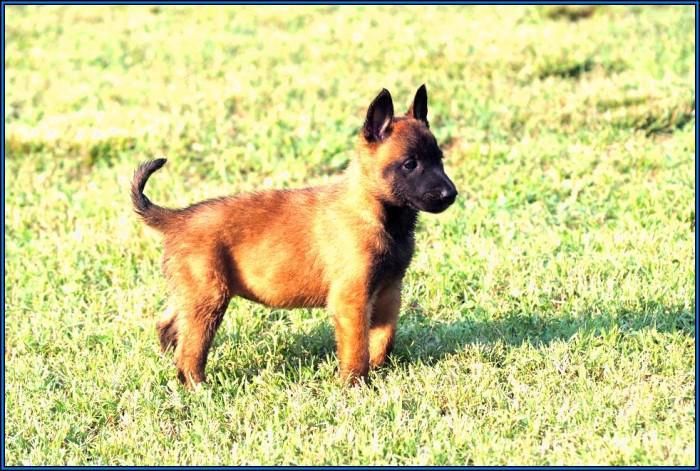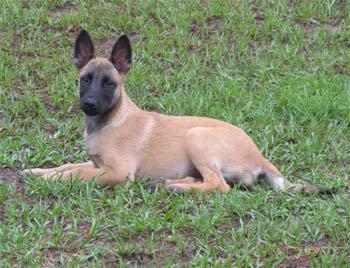The first image is the image on the left, the second image is the image on the right. Examine the images to the left and right. Is the description "the right image has a dog standing on all 4's with a taught leash" accurate? Answer yes or no. No. The first image is the image on the left, the second image is the image on the right. Analyze the images presented: Is the assertion "There is a total of 1 dog facing right is a grassy area." valid? Answer yes or no. Yes. 